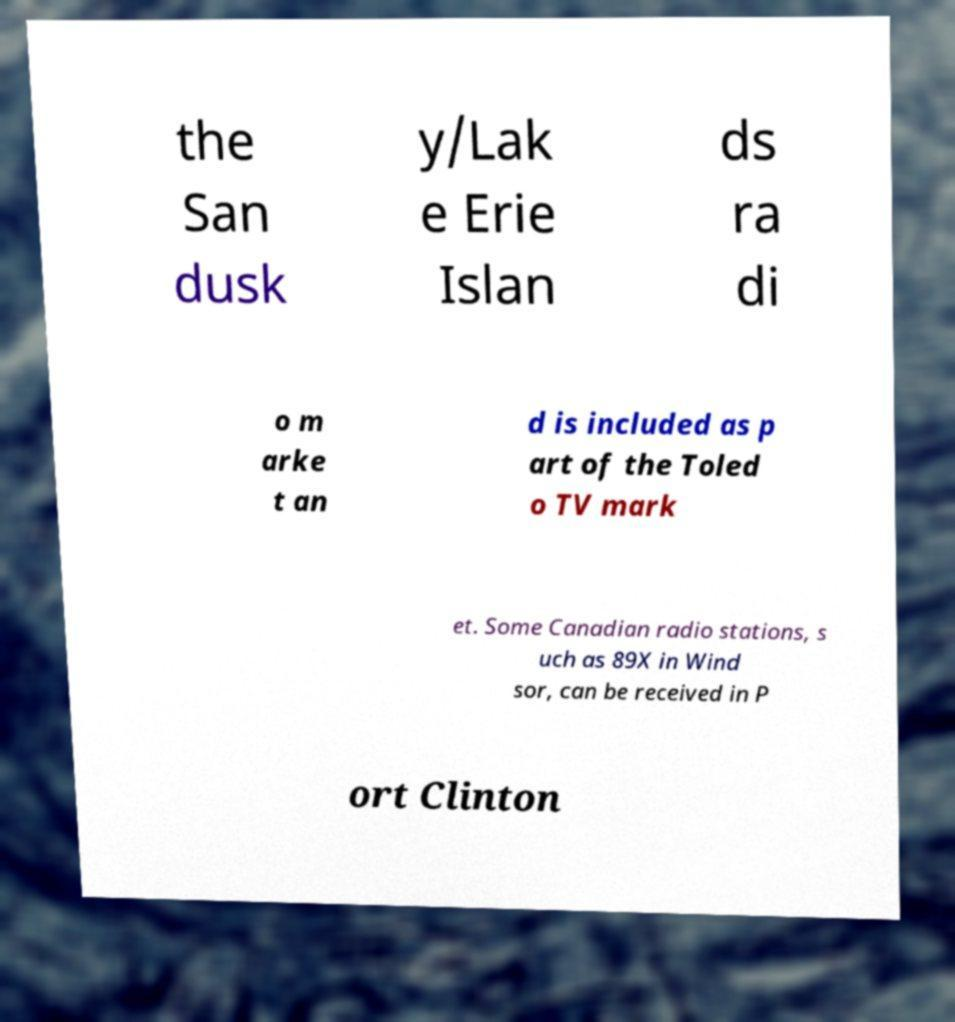Could you assist in decoding the text presented in this image and type it out clearly? the San dusk y/Lak e Erie Islan ds ra di o m arke t an d is included as p art of the Toled o TV mark et. Some Canadian radio stations, s uch as 89X in Wind sor, can be received in P ort Clinton 